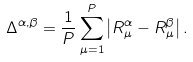Convert formula to latex. <formula><loc_0><loc_0><loc_500><loc_500>\Delta ^ { \alpha , \beta } = \frac { 1 } { P } \sum _ { \mu = 1 } ^ { P } \left | R _ { \mu } ^ { \alpha } - R _ { \mu } ^ { \beta } \right | .</formula> 